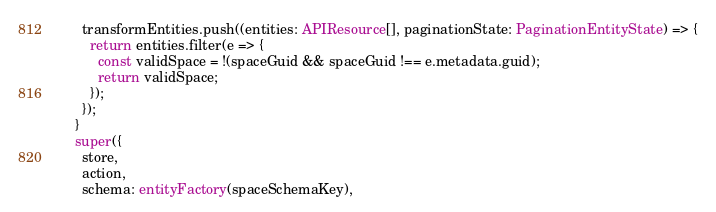Convert code to text. <code><loc_0><loc_0><loc_500><loc_500><_TypeScript_>      transformEntities.push((entities: APIResource[], paginationState: PaginationEntityState) => {
        return entities.filter(e => {
          const validSpace = !(spaceGuid && spaceGuid !== e.metadata.guid);
          return validSpace;
        });
      });
    }
    super({
      store,
      action,
      schema: entityFactory(spaceSchemaKey),</code> 